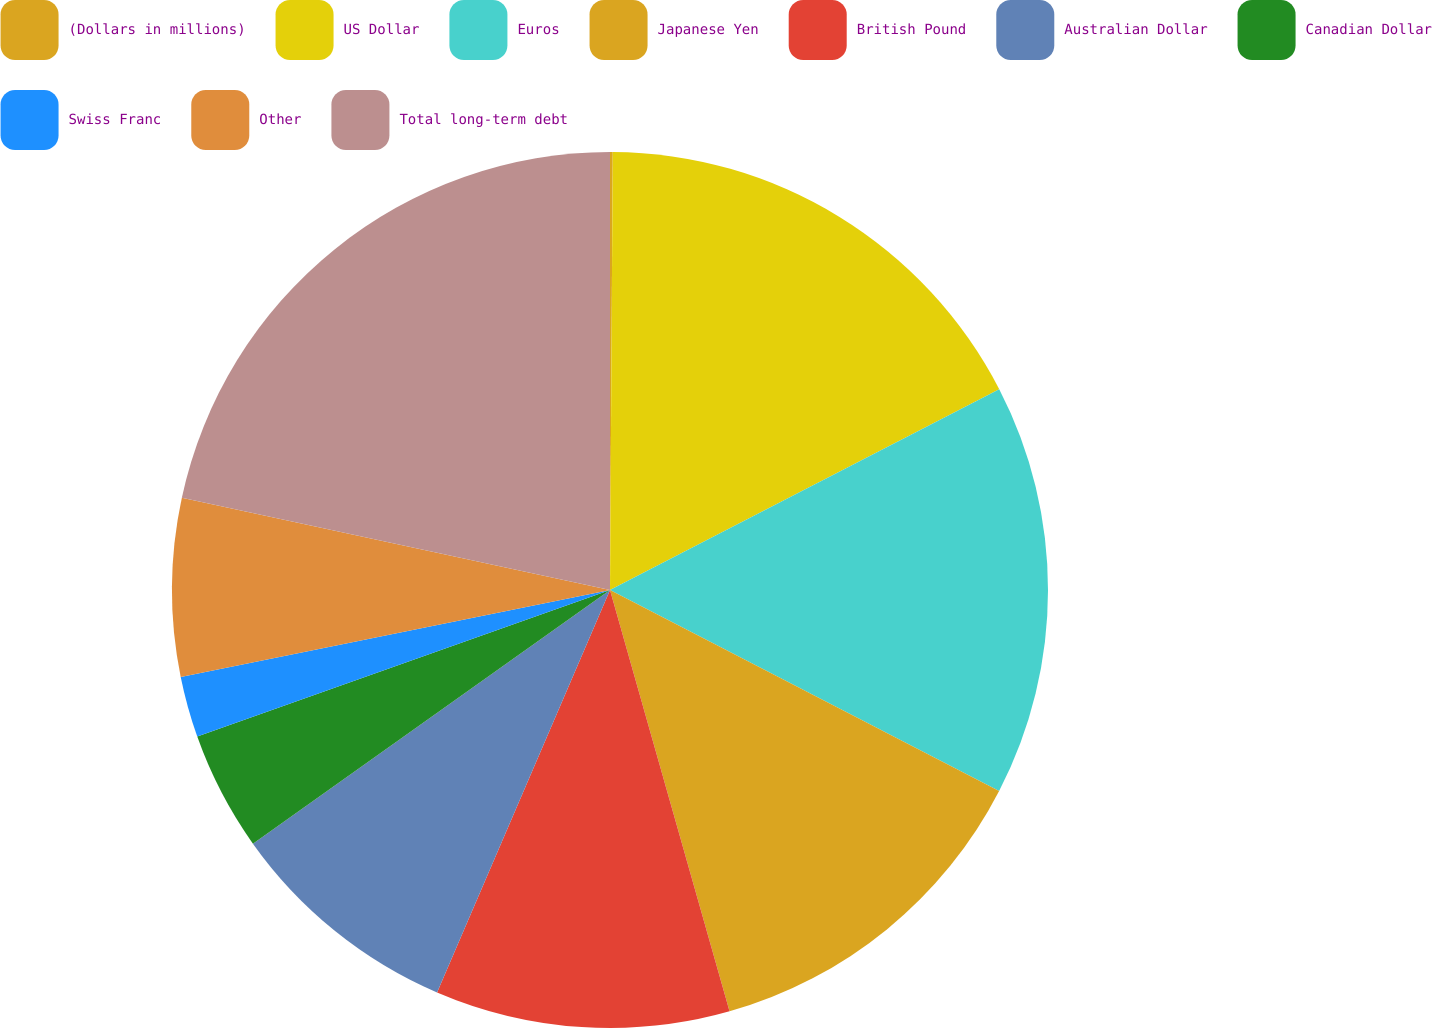Convert chart to OTSL. <chart><loc_0><loc_0><loc_500><loc_500><pie_chart><fcel>(Dollars in millions)<fcel>US Dollar<fcel>Euros<fcel>Japanese Yen<fcel>British Pound<fcel>Australian Dollar<fcel>Canadian Dollar<fcel>Swiss Franc<fcel>Other<fcel>Total long-term debt<nl><fcel>0.1%<fcel>17.32%<fcel>15.17%<fcel>13.01%<fcel>10.86%<fcel>8.71%<fcel>4.4%<fcel>2.25%<fcel>6.56%<fcel>21.62%<nl></chart> 